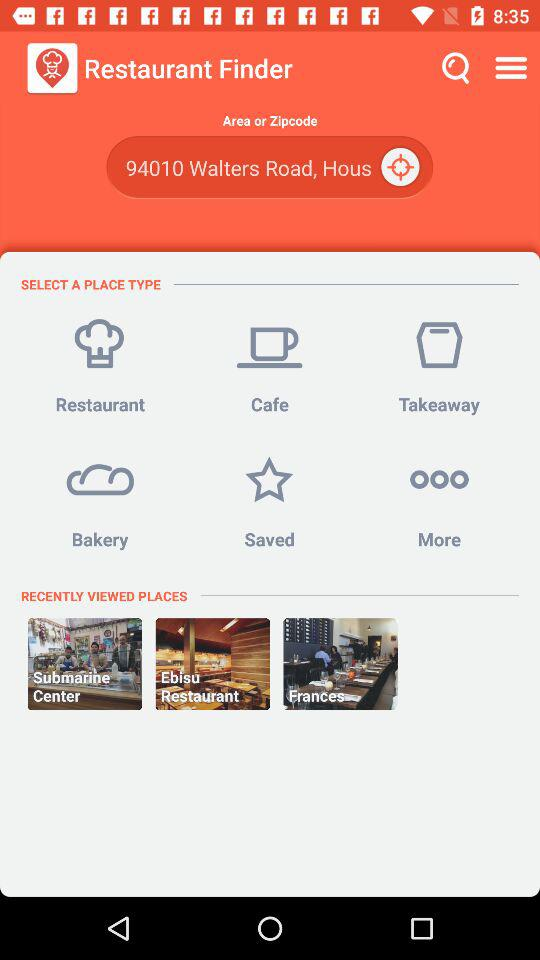What's the area zip code? The area zip code is 94010. 